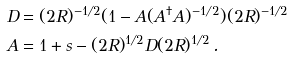Convert formula to latex. <formula><loc_0><loc_0><loc_500><loc_500>\ D & = ( 2 R ) ^ { - 1 / 2 } ( 1 - A ( A ^ { \dagger } A ) ^ { - 1 / 2 } ) ( 2 R ) ^ { - 1 / 2 } \\ A & = 1 + s - ( 2 R ) ^ { 1 / 2 } D ( 2 R ) ^ { 1 / 2 } \, .</formula> 